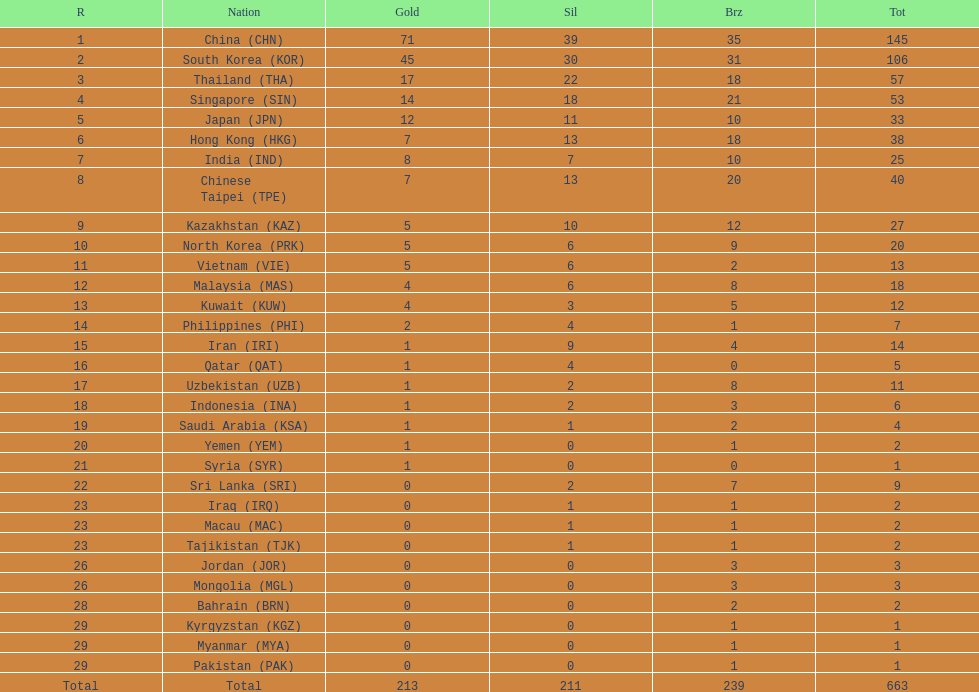How does the total medal count for qatar and indonesia differ? 1. 